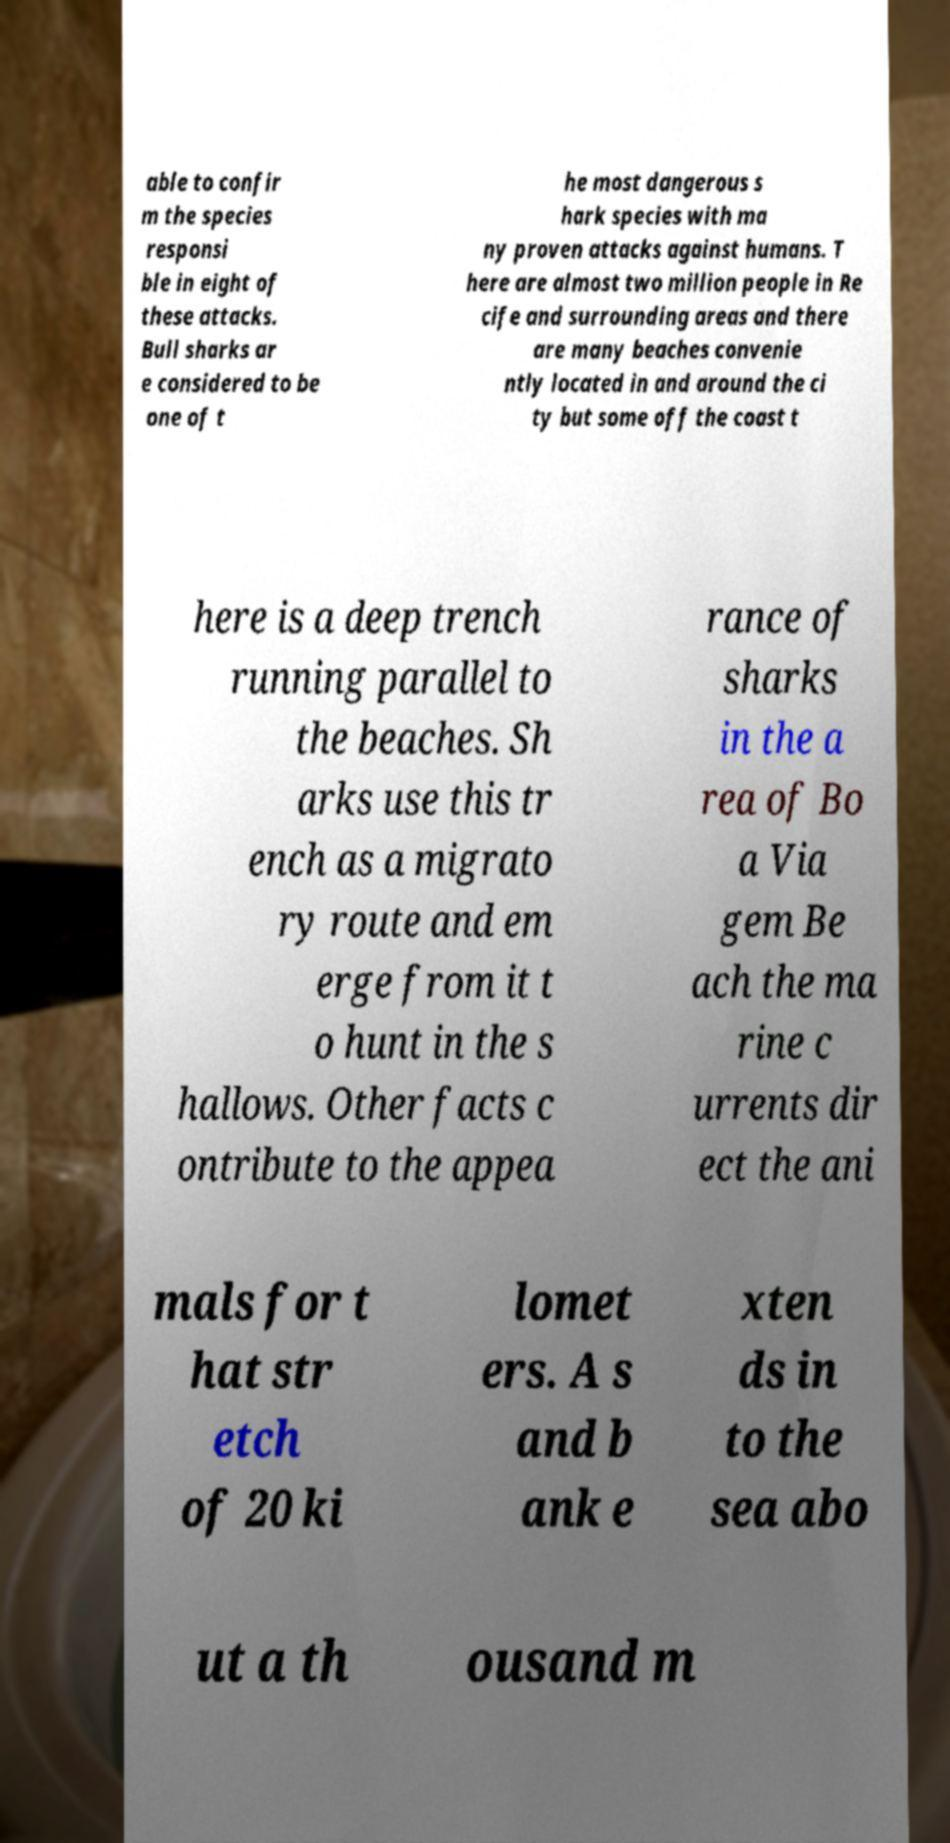Can you read and provide the text displayed in the image?This photo seems to have some interesting text. Can you extract and type it out for me? able to confir m the species responsi ble in eight of these attacks. Bull sharks ar e considered to be one of t he most dangerous s hark species with ma ny proven attacks against humans. T here are almost two million people in Re cife and surrounding areas and there are many beaches convenie ntly located in and around the ci ty but some off the coast t here is a deep trench running parallel to the beaches. Sh arks use this tr ench as a migrato ry route and em erge from it t o hunt in the s hallows. Other facts c ontribute to the appea rance of sharks in the a rea of Bo a Via gem Be ach the ma rine c urrents dir ect the ani mals for t hat str etch of 20 ki lomet ers. A s and b ank e xten ds in to the sea abo ut a th ousand m 